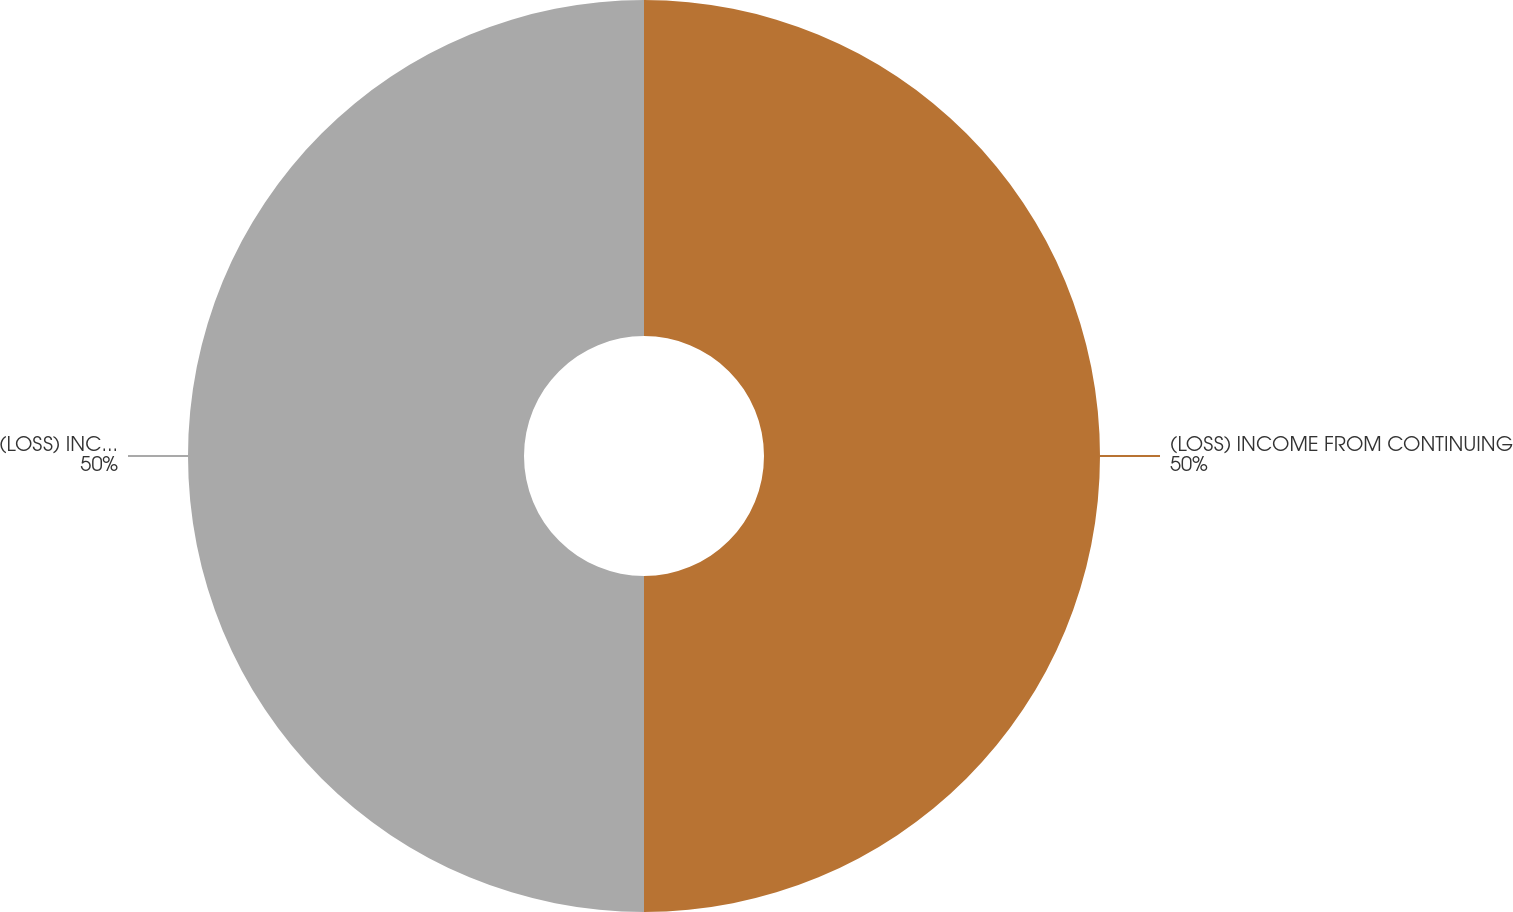Convert chart to OTSL. <chart><loc_0><loc_0><loc_500><loc_500><pie_chart><fcel>(LOSS) INCOME FROM CONTINUING<fcel>(LOSS) INCOME BEFORE<nl><fcel>50.0%<fcel>50.0%<nl></chart> 